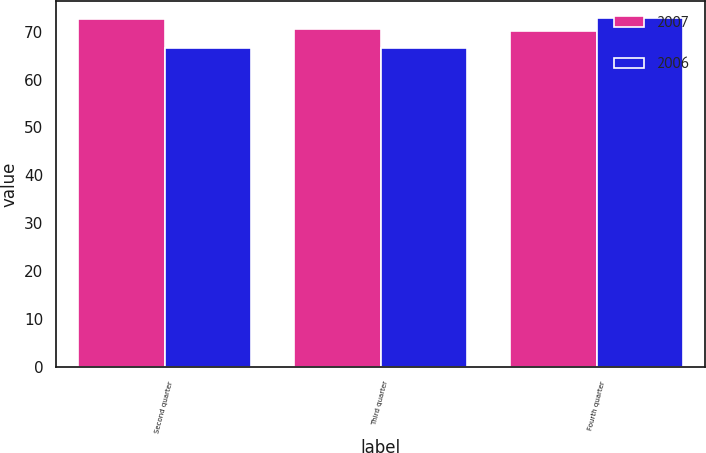Convert chart to OTSL. <chart><loc_0><loc_0><loc_500><loc_500><stacked_bar_chart><ecel><fcel>Second quarter<fcel>Third quarter<fcel>Fourth quarter<nl><fcel>2007<fcel>72.65<fcel>70.44<fcel>70.11<nl><fcel>2006<fcel>66.54<fcel>66.48<fcel>72.81<nl></chart> 